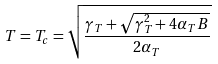<formula> <loc_0><loc_0><loc_500><loc_500>T = T _ { c } = \sqrt { \frac { \gamma _ { T } + \sqrt { \gamma _ { T } ^ { 2 } + 4 \alpha _ { T } B } } { 2 \alpha _ { T } } }</formula> 